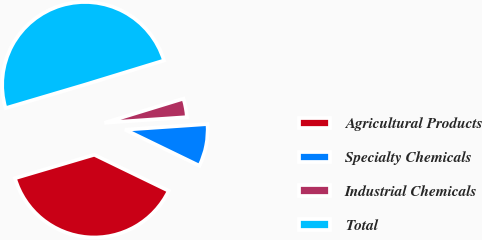Convert chart to OTSL. <chart><loc_0><loc_0><loc_500><loc_500><pie_chart><fcel>Agricultural Products<fcel>Specialty Chemicals<fcel>Industrial Chemicals<fcel>Total<nl><fcel>38.24%<fcel>8.27%<fcel>3.64%<fcel>49.85%<nl></chart> 